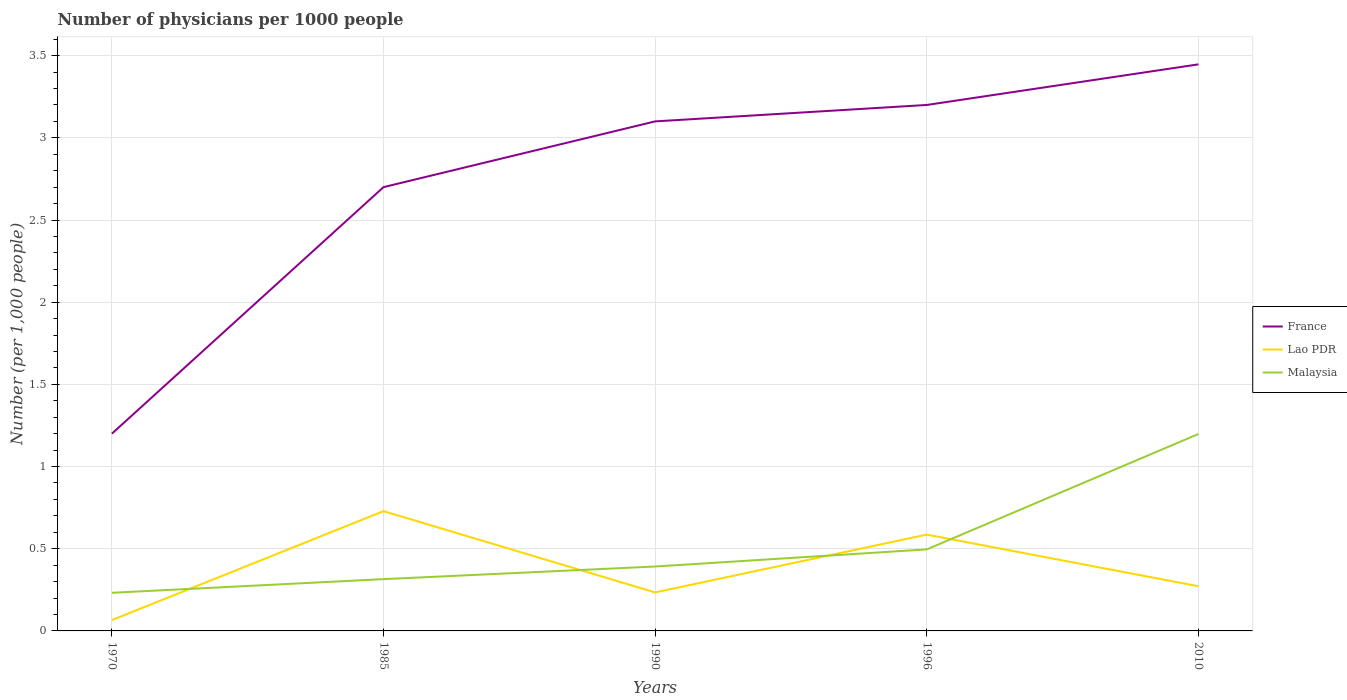How many different coloured lines are there?
Your response must be concise. 3. Does the line corresponding to Lao PDR intersect with the line corresponding to Malaysia?
Provide a short and direct response. Yes. Across all years, what is the maximum number of physicians in Malaysia?
Offer a very short reply. 0.23. What is the total number of physicians in Lao PDR in the graph?
Provide a succinct answer. -0.66. What is the difference between the highest and the second highest number of physicians in France?
Your response must be concise. 2.25. Is the number of physicians in Lao PDR strictly greater than the number of physicians in Malaysia over the years?
Your answer should be very brief. No. How many years are there in the graph?
Keep it short and to the point. 5. Does the graph contain any zero values?
Give a very brief answer. No. How many legend labels are there?
Provide a succinct answer. 3. What is the title of the graph?
Offer a terse response. Number of physicians per 1000 people. What is the label or title of the X-axis?
Provide a short and direct response. Years. What is the label or title of the Y-axis?
Your answer should be very brief. Number (per 1,0 people). What is the Number (per 1,000 people) of Lao PDR in 1970?
Keep it short and to the point. 0.07. What is the Number (per 1,000 people) of Malaysia in 1970?
Offer a terse response. 0.23. What is the Number (per 1,000 people) in France in 1985?
Your answer should be compact. 2.7. What is the Number (per 1,000 people) of Lao PDR in 1985?
Provide a succinct answer. 0.73. What is the Number (per 1,000 people) in Malaysia in 1985?
Provide a short and direct response. 0.31. What is the Number (per 1,000 people) of France in 1990?
Provide a short and direct response. 3.1. What is the Number (per 1,000 people) in Lao PDR in 1990?
Provide a succinct answer. 0.23. What is the Number (per 1,000 people) of Malaysia in 1990?
Your answer should be very brief. 0.39. What is the Number (per 1,000 people) in Lao PDR in 1996?
Keep it short and to the point. 0.59. What is the Number (per 1,000 people) of Malaysia in 1996?
Provide a short and direct response. 0.5. What is the Number (per 1,000 people) of France in 2010?
Make the answer very short. 3.45. What is the Number (per 1,000 people) of Lao PDR in 2010?
Keep it short and to the point. 0.27. What is the Number (per 1,000 people) of Malaysia in 2010?
Give a very brief answer. 1.2. Across all years, what is the maximum Number (per 1,000 people) in France?
Make the answer very short. 3.45. Across all years, what is the maximum Number (per 1,000 people) of Lao PDR?
Provide a succinct answer. 0.73. Across all years, what is the maximum Number (per 1,000 people) of Malaysia?
Give a very brief answer. 1.2. Across all years, what is the minimum Number (per 1,000 people) of France?
Provide a succinct answer. 1.2. Across all years, what is the minimum Number (per 1,000 people) in Lao PDR?
Keep it short and to the point. 0.07. Across all years, what is the minimum Number (per 1,000 people) in Malaysia?
Provide a succinct answer. 0.23. What is the total Number (per 1,000 people) in France in the graph?
Offer a terse response. 13.65. What is the total Number (per 1,000 people) of Lao PDR in the graph?
Give a very brief answer. 1.89. What is the total Number (per 1,000 people) in Malaysia in the graph?
Provide a short and direct response. 2.63. What is the difference between the Number (per 1,000 people) in France in 1970 and that in 1985?
Make the answer very short. -1.5. What is the difference between the Number (per 1,000 people) in Lao PDR in 1970 and that in 1985?
Keep it short and to the point. -0.66. What is the difference between the Number (per 1,000 people) in Malaysia in 1970 and that in 1985?
Offer a very short reply. -0.08. What is the difference between the Number (per 1,000 people) in Lao PDR in 1970 and that in 1990?
Make the answer very short. -0.17. What is the difference between the Number (per 1,000 people) in Malaysia in 1970 and that in 1990?
Make the answer very short. -0.16. What is the difference between the Number (per 1,000 people) of France in 1970 and that in 1996?
Give a very brief answer. -2. What is the difference between the Number (per 1,000 people) of Lao PDR in 1970 and that in 1996?
Ensure brevity in your answer.  -0.52. What is the difference between the Number (per 1,000 people) of Malaysia in 1970 and that in 1996?
Your response must be concise. -0.26. What is the difference between the Number (per 1,000 people) in France in 1970 and that in 2010?
Make the answer very short. -2.25. What is the difference between the Number (per 1,000 people) in Lao PDR in 1970 and that in 2010?
Offer a terse response. -0.21. What is the difference between the Number (per 1,000 people) of Malaysia in 1970 and that in 2010?
Keep it short and to the point. -0.97. What is the difference between the Number (per 1,000 people) in France in 1985 and that in 1990?
Provide a short and direct response. -0.4. What is the difference between the Number (per 1,000 people) of Lao PDR in 1985 and that in 1990?
Make the answer very short. 0.49. What is the difference between the Number (per 1,000 people) in Malaysia in 1985 and that in 1990?
Provide a succinct answer. -0.08. What is the difference between the Number (per 1,000 people) of Lao PDR in 1985 and that in 1996?
Your response must be concise. 0.14. What is the difference between the Number (per 1,000 people) of Malaysia in 1985 and that in 1996?
Provide a short and direct response. -0.18. What is the difference between the Number (per 1,000 people) in France in 1985 and that in 2010?
Your response must be concise. -0.75. What is the difference between the Number (per 1,000 people) in Lao PDR in 1985 and that in 2010?
Your response must be concise. 0.46. What is the difference between the Number (per 1,000 people) in Malaysia in 1985 and that in 2010?
Keep it short and to the point. -0.88. What is the difference between the Number (per 1,000 people) of Lao PDR in 1990 and that in 1996?
Your answer should be very brief. -0.35. What is the difference between the Number (per 1,000 people) of Malaysia in 1990 and that in 1996?
Make the answer very short. -0.1. What is the difference between the Number (per 1,000 people) of France in 1990 and that in 2010?
Your response must be concise. -0.35. What is the difference between the Number (per 1,000 people) of Lao PDR in 1990 and that in 2010?
Offer a terse response. -0.04. What is the difference between the Number (per 1,000 people) in Malaysia in 1990 and that in 2010?
Give a very brief answer. -0.81. What is the difference between the Number (per 1,000 people) of France in 1996 and that in 2010?
Ensure brevity in your answer.  -0.25. What is the difference between the Number (per 1,000 people) in Lao PDR in 1996 and that in 2010?
Your response must be concise. 0.31. What is the difference between the Number (per 1,000 people) of Malaysia in 1996 and that in 2010?
Offer a very short reply. -0.7. What is the difference between the Number (per 1,000 people) of France in 1970 and the Number (per 1,000 people) of Lao PDR in 1985?
Provide a short and direct response. 0.47. What is the difference between the Number (per 1,000 people) of France in 1970 and the Number (per 1,000 people) of Malaysia in 1985?
Keep it short and to the point. 0.89. What is the difference between the Number (per 1,000 people) in Lao PDR in 1970 and the Number (per 1,000 people) in Malaysia in 1985?
Make the answer very short. -0.25. What is the difference between the Number (per 1,000 people) in France in 1970 and the Number (per 1,000 people) in Lao PDR in 1990?
Give a very brief answer. 0.97. What is the difference between the Number (per 1,000 people) in France in 1970 and the Number (per 1,000 people) in Malaysia in 1990?
Ensure brevity in your answer.  0.81. What is the difference between the Number (per 1,000 people) in Lao PDR in 1970 and the Number (per 1,000 people) in Malaysia in 1990?
Your answer should be very brief. -0.33. What is the difference between the Number (per 1,000 people) of France in 1970 and the Number (per 1,000 people) of Lao PDR in 1996?
Ensure brevity in your answer.  0.61. What is the difference between the Number (per 1,000 people) in France in 1970 and the Number (per 1,000 people) in Malaysia in 1996?
Provide a short and direct response. 0.7. What is the difference between the Number (per 1,000 people) in Lao PDR in 1970 and the Number (per 1,000 people) in Malaysia in 1996?
Make the answer very short. -0.43. What is the difference between the Number (per 1,000 people) in France in 1970 and the Number (per 1,000 people) in Lao PDR in 2010?
Keep it short and to the point. 0.93. What is the difference between the Number (per 1,000 people) in France in 1970 and the Number (per 1,000 people) in Malaysia in 2010?
Make the answer very short. 0. What is the difference between the Number (per 1,000 people) of Lao PDR in 1970 and the Number (per 1,000 people) of Malaysia in 2010?
Provide a succinct answer. -1.13. What is the difference between the Number (per 1,000 people) in France in 1985 and the Number (per 1,000 people) in Lao PDR in 1990?
Give a very brief answer. 2.47. What is the difference between the Number (per 1,000 people) of France in 1985 and the Number (per 1,000 people) of Malaysia in 1990?
Make the answer very short. 2.31. What is the difference between the Number (per 1,000 people) of Lao PDR in 1985 and the Number (per 1,000 people) of Malaysia in 1990?
Make the answer very short. 0.34. What is the difference between the Number (per 1,000 people) of France in 1985 and the Number (per 1,000 people) of Lao PDR in 1996?
Provide a short and direct response. 2.11. What is the difference between the Number (per 1,000 people) in France in 1985 and the Number (per 1,000 people) in Malaysia in 1996?
Give a very brief answer. 2.2. What is the difference between the Number (per 1,000 people) in Lao PDR in 1985 and the Number (per 1,000 people) in Malaysia in 1996?
Your response must be concise. 0.23. What is the difference between the Number (per 1,000 people) in France in 1985 and the Number (per 1,000 people) in Lao PDR in 2010?
Offer a very short reply. 2.43. What is the difference between the Number (per 1,000 people) of France in 1985 and the Number (per 1,000 people) of Malaysia in 2010?
Ensure brevity in your answer.  1.5. What is the difference between the Number (per 1,000 people) in Lao PDR in 1985 and the Number (per 1,000 people) in Malaysia in 2010?
Offer a very short reply. -0.47. What is the difference between the Number (per 1,000 people) in France in 1990 and the Number (per 1,000 people) in Lao PDR in 1996?
Provide a succinct answer. 2.51. What is the difference between the Number (per 1,000 people) of France in 1990 and the Number (per 1,000 people) of Malaysia in 1996?
Provide a short and direct response. 2.6. What is the difference between the Number (per 1,000 people) in Lao PDR in 1990 and the Number (per 1,000 people) in Malaysia in 1996?
Offer a terse response. -0.26. What is the difference between the Number (per 1,000 people) in France in 1990 and the Number (per 1,000 people) in Lao PDR in 2010?
Offer a terse response. 2.83. What is the difference between the Number (per 1,000 people) of France in 1990 and the Number (per 1,000 people) of Malaysia in 2010?
Your answer should be very brief. 1.9. What is the difference between the Number (per 1,000 people) of Lao PDR in 1990 and the Number (per 1,000 people) of Malaysia in 2010?
Make the answer very short. -0.96. What is the difference between the Number (per 1,000 people) of France in 1996 and the Number (per 1,000 people) of Lao PDR in 2010?
Offer a terse response. 2.93. What is the difference between the Number (per 1,000 people) in France in 1996 and the Number (per 1,000 people) in Malaysia in 2010?
Your response must be concise. 2. What is the difference between the Number (per 1,000 people) in Lao PDR in 1996 and the Number (per 1,000 people) in Malaysia in 2010?
Your response must be concise. -0.61. What is the average Number (per 1,000 people) in France per year?
Ensure brevity in your answer.  2.73. What is the average Number (per 1,000 people) in Lao PDR per year?
Give a very brief answer. 0.38. What is the average Number (per 1,000 people) of Malaysia per year?
Your answer should be compact. 0.53. In the year 1970, what is the difference between the Number (per 1,000 people) in France and Number (per 1,000 people) in Lao PDR?
Provide a succinct answer. 1.13. In the year 1970, what is the difference between the Number (per 1,000 people) in France and Number (per 1,000 people) in Malaysia?
Provide a short and direct response. 0.97. In the year 1970, what is the difference between the Number (per 1,000 people) in Lao PDR and Number (per 1,000 people) in Malaysia?
Your answer should be very brief. -0.17. In the year 1985, what is the difference between the Number (per 1,000 people) of France and Number (per 1,000 people) of Lao PDR?
Your answer should be compact. 1.97. In the year 1985, what is the difference between the Number (per 1,000 people) of France and Number (per 1,000 people) of Malaysia?
Give a very brief answer. 2.38. In the year 1985, what is the difference between the Number (per 1,000 people) in Lao PDR and Number (per 1,000 people) in Malaysia?
Your answer should be compact. 0.41. In the year 1990, what is the difference between the Number (per 1,000 people) in France and Number (per 1,000 people) in Lao PDR?
Offer a terse response. 2.87. In the year 1990, what is the difference between the Number (per 1,000 people) in France and Number (per 1,000 people) in Malaysia?
Make the answer very short. 2.71. In the year 1990, what is the difference between the Number (per 1,000 people) of Lao PDR and Number (per 1,000 people) of Malaysia?
Offer a very short reply. -0.16. In the year 1996, what is the difference between the Number (per 1,000 people) in France and Number (per 1,000 people) in Lao PDR?
Make the answer very short. 2.61. In the year 1996, what is the difference between the Number (per 1,000 people) of France and Number (per 1,000 people) of Malaysia?
Provide a short and direct response. 2.7. In the year 1996, what is the difference between the Number (per 1,000 people) in Lao PDR and Number (per 1,000 people) in Malaysia?
Provide a short and direct response. 0.09. In the year 2010, what is the difference between the Number (per 1,000 people) of France and Number (per 1,000 people) of Lao PDR?
Keep it short and to the point. 3.17. In the year 2010, what is the difference between the Number (per 1,000 people) in France and Number (per 1,000 people) in Malaysia?
Give a very brief answer. 2.25. In the year 2010, what is the difference between the Number (per 1,000 people) in Lao PDR and Number (per 1,000 people) in Malaysia?
Ensure brevity in your answer.  -0.93. What is the ratio of the Number (per 1,000 people) in France in 1970 to that in 1985?
Give a very brief answer. 0.44. What is the ratio of the Number (per 1,000 people) in Lao PDR in 1970 to that in 1985?
Keep it short and to the point. 0.09. What is the ratio of the Number (per 1,000 people) of Malaysia in 1970 to that in 1985?
Your response must be concise. 0.74. What is the ratio of the Number (per 1,000 people) of France in 1970 to that in 1990?
Provide a succinct answer. 0.39. What is the ratio of the Number (per 1,000 people) in Lao PDR in 1970 to that in 1990?
Your answer should be very brief. 0.28. What is the ratio of the Number (per 1,000 people) of Malaysia in 1970 to that in 1990?
Your response must be concise. 0.59. What is the ratio of the Number (per 1,000 people) in Lao PDR in 1970 to that in 1996?
Make the answer very short. 0.11. What is the ratio of the Number (per 1,000 people) of Malaysia in 1970 to that in 1996?
Provide a succinct answer. 0.47. What is the ratio of the Number (per 1,000 people) of France in 1970 to that in 2010?
Make the answer very short. 0.35. What is the ratio of the Number (per 1,000 people) in Lao PDR in 1970 to that in 2010?
Keep it short and to the point. 0.24. What is the ratio of the Number (per 1,000 people) in Malaysia in 1970 to that in 2010?
Provide a succinct answer. 0.19. What is the ratio of the Number (per 1,000 people) in France in 1985 to that in 1990?
Keep it short and to the point. 0.87. What is the ratio of the Number (per 1,000 people) in Lao PDR in 1985 to that in 1990?
Offer a terse response. 3.11. What is the ratio of the Number (per 1,000 people) in Malaysia in 1985 to that in 1990?
Offer a very short reply. 0.8. What is the ratio of the Number (per 1,000 people) in France in 1985 to that in 1996?
Your response must be concise. 0.84. What is the ratio of the Number (per 1,000 people) in Lao PDR in 1985 to that in 1996?
Offer a very short reply. 1.24. What is the ratio of the Number (per 1,000 people) in Malaysia in 1985 to that in 1996?
Your answer should be very brief. 0.64. What is the ratio of the Number (per 1,000 people) of France in 1985 to that in 2010?
Your answer should be very brief. 0.78. What is the ratio of the Number (per 1,000 people) of Lao PDR in 1985 to that in 2010?
Offer a very short reply. 2.68. What is the ratio of the Number (per 1,000 people) in Malaysia in 1985 to that in 2010?
Offer a very short reply. 0.26. What is the ratio of the Number (per 1,000 people) in France in 1990 to that in 1996?
Make the answer very short. 0.97. What is the ratio of the Number (per 1,000 people) of Lao PDR in 1990 to that in 1996?
Offer a very short reply. 0.4. What is the ratio of the Number (per 1,000 people) in Malaysia in 1990 to that in 1996?
Provide a short and direct response. 0.79. What is the ratio of the Number (per 1,000 people) in France in 1990 to that in 2010?
Offer a very short reply. 0.9. What is the ratio of the Number (per 1,000 people) of Lao PDR in 1990 to that in 2010?
Provide a succinct answer. 0.86. What is the ratio of the Number (per 1,000 people) of Malaysia in 1990 to that in 2010?
Your response must be concise. 0.33. What is the ratio of the Number (per 1,000 people) of France in 1996 to that in 2010?
Provide a short and direct response. 0.93. What is the ratio of the Number (per 1,000 people) in Lao PDR in 1996 to that in 2010?
Give a very brief answer. 2.15. What is the ratio of the Number (per 1,000 people) in Malaysia in 1996 to that in 2010?
Ensure brevity in your answer.  0.41. What is the difference between the highest and the second highest Number (per 1,000 people) in France?
Offer a terse response. 0.25. What is the difference between the highest and the second highest Number (per 1,000 people) in Lao PDR?
Ensure brevity in your answer.  0.14. What is the difference between the highest and the second highest Number (per 1,000 people) in Malaysia?
Your answer should be compact. 0.7. What is the difference between the highest and the lowest Number (per 1,000 people) in France?
Your answer should be very brief. 2.25. What is the difference between the highest and the lowest Number (per 1,000 people) of Lao PDR?
Give a very brief answer. 0.66. 